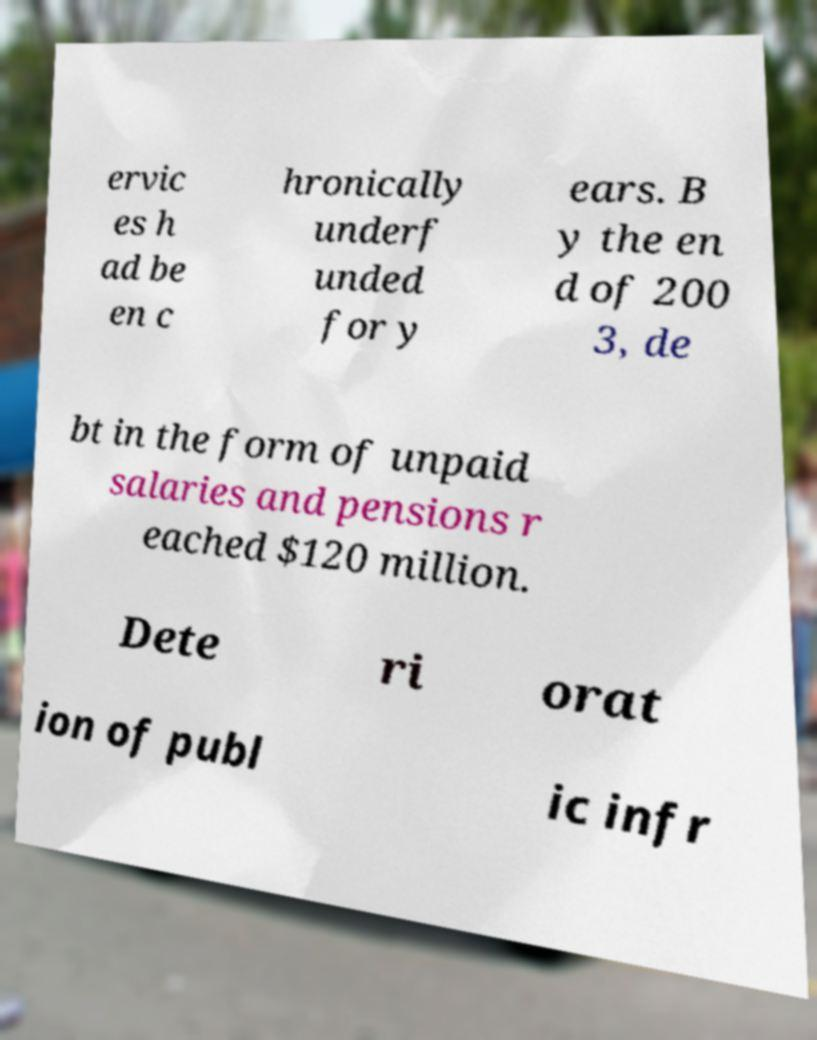Please read and relay the text visible in this image. What does it say? ervic es h ad be en c hronically underf unded for y ears. B y the en d of 200 3, de bt in the form of unpaid salaries and pensions r eached $120 million. Dete ri orat ion of publ ic infr 